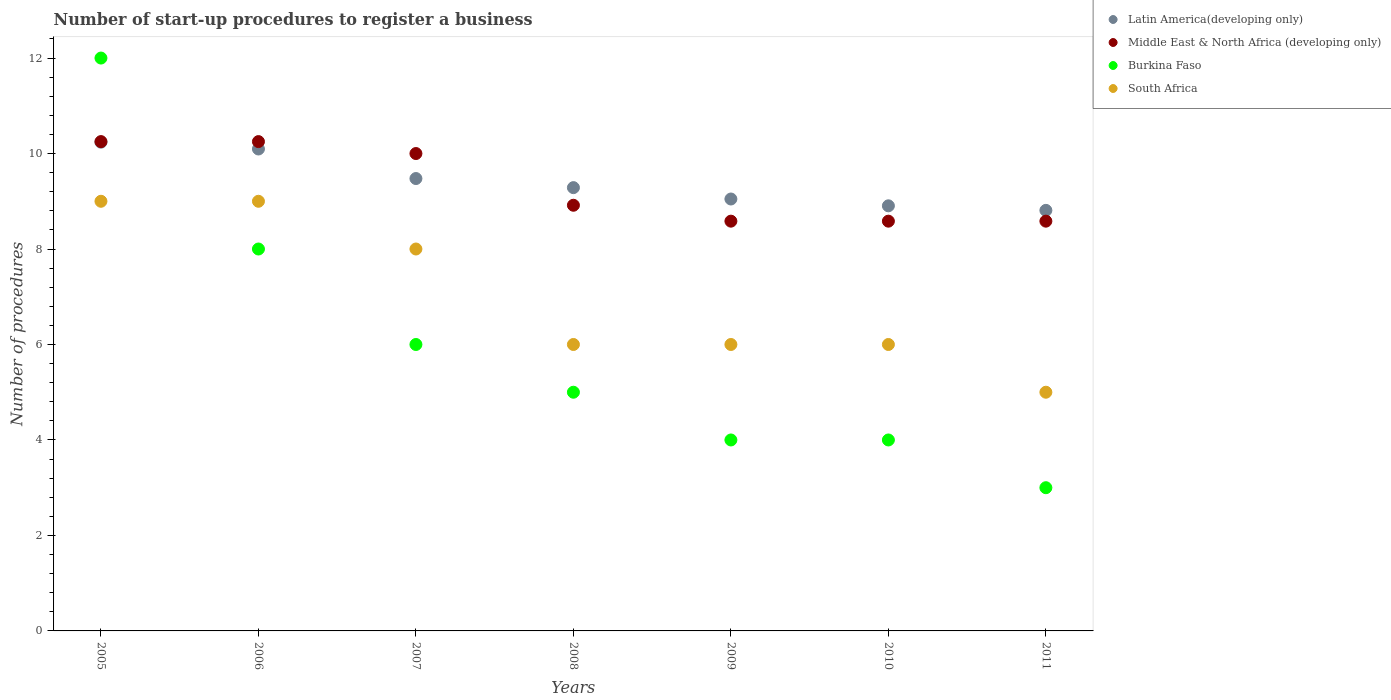How many different coloured dotlines are there?
Your answer should be compact. 4. What is the number of procedures required to register a business in Middle East & North Africa (developing only) in 2006?
Make the answer very short. 10.25. Across all years, what is the maximum number of procedures required to register a business in South Africa?
Your response must be concise. 9. Across all years, what is the minimum number of procedures required to register a business in Latin America(developing only)?
Your answer should be very brief. 8.81. What is the total number of procedures required to register a business in Middle East & North Africa (developing only) in the graph?
Make the answer very short. 65.17. What is the difference between the number of procedures required to register a business in Middle East & North Africa (developing only) in 2006 and that in 2009?
Your answer should be compact. 1.67. What is the difference between the number of procedures required to register a business in South Africa in 2011 and the number of procedures required to register a business in Burkina Faso in 2005?
Make the answer very short. -7. What is the average number of procedures required to register a business in Burkina Faso per year?
Offer a terse response. 6. In the year 2009, what is the difference between the number of procedures required to register a business in Latin America(developing only) and number of procedures required to register a business in South Africa?
Offer a terse response. 3.05. What is the ratio of the number of procedures required to register a business in Latin America(developing only) in 2008 to that in 2010?
Ensure brevity in your answer.  1.04. Is the difference between the number of procedures required to register a business in Latin America(developing only) in 2005 and 2007 greater than the difference between the number of procedures required to register a business in South Africa in 2005 and 2007?
Make the answer very short. No. What is the difference between the highest and the lowest number of procedures required to register a business in Burkina Faso?
Offer a terse response. 9. In how many years, is the number of procedures required to register a business in Middle East & North Africa (developing only) greater than the average number of procedures required to register a business in Middle East & North Africa (developing only) taken over all years?
Offer a very short reply. 3. Is the sum of the number of procedures required to register a business in South Africa in 2005 and 2010 greater than the maximum number of procedures required to register a business in Middle East & North Africa (developing only) across all years?
Ensure brevity in your answer.  Yes. Is the number of procedures required to register a business in Latin America(developing only) strictly greater than the number of procedures required to register a business in Burkina Faso over the years?
Your response must be concise. No. Is the number of procedures required to register a business in South Africa strictly less than the number of procedures required to register a business in Latin America(developing only) over the years?
Provide a succinct answer. Yes. Are the values on the major ticks of Y-axis written in scientific E-notation?
Give a very brief answer. No. Does the graph contain grids?
Offer a terse response. No. Where does the legend appear in the graph?
Give a very brief answer. Top right. How are the legend labels stacked?
Your answer should be compact. Vertical. What is the title of the graph?
Your answer should be very brief. Number of start-up procedures to register a business. Does "Congo (Democratic)" appear as one of the legend labels in the graph?
Your answer should be compact. No. What is the label or title of the Y-axis?
Provide a short and direct response. Number of procedures. What is the Number of procedures in Latin America(developing only) in 2005?
Give a very brief answer. 10.24. What is the Number of procedures of Middle East & North Africa (developing only) in 2005?
Provide a short and direct response. 10.25. What is the Number of procedures in South Africa in 2005?
Your answer should be compact. 9. What is the Number of procedures of Latin America(developing only) in 2006?
Give a very brief answer. 10.1. What is the Number of procedures of Middle East & North Africa (developing only) in 2006?
Offer a very short reply. 10.25. What is the Number of procedures in Latin America(developing only) in 2007?
Keep it short and to the point. 9.48. What is the Number of procedures of South Africa in 2007?
Give a very brief answer. 8. What is the Number of procedures in Latin America(developing only) in 2008?
Make the answer very short. 9.29. What is the Number of procedures in Middle East & North Africa (developing only) in 2008?
Offer a terse response. 8.92. What is the Number of procedures of South Africa in 2008?
Your answer should be compact. 6. What is the Number of procedures in Latin America(developing only) in 2009?
Ensure brevity in your answer.  9.05. What is the Number of procedures of Middle East & North Africa (developing only) in 2009?
Offer a terse response. 8.58. What is the Number of procedures in South Africa in 2009?
Your answer should be very brief. 6. What is the Number of procedures in Latin America(developing only) in 2010?
Your answer should be very brief. 8.9. What is the Number of procedures in Middle East & North Africa (developing only) in 2010?
Offer a very short reply. 8.58. What is the Number of procedures of Burkina Faso in 2010?
Keep it short and to the point. 4. What is the Number of procedures of South Africa in 2010?
Your response must be concise. 6. What is the Number of procedures in Latin America(developing only) in 2011?
Offer a terse response. 8.81. What is the Number of procedures in Middle East & North Africa (developing only) in 2011?
Ensure brevity in your answer.  8.58. What is the Number of procedures in Burkina Faso in 2011?
Make the answer very short. 3. What is the Number of procedures in South Africa in 2011?
Ensure brevity in your answer.  5. Across all years, what is the maximum Number of procedures of Latin America(developing only)?
Offer a very short reply. 10.24. Across all years, what is the maximum Number of procedures of Middle East & North Africa (developing only)?
Offer a terse response. 10.25. Across all years, what is the maximum Number of procedures in South Africa?
Offer a very short reply. 9. Across all years, what is the minimum Number of procedures in Latin America(developing only)?
Provide a succinct answer. 8.81. Across all years, what is the minimum Number of procedures of Middle East & North Africa (developing only)?
Offer a terse response. 8.58. Across all years, what is the minimum Number of procedures in South Africa?
Keep it short and to the point. 5. What is the total Number of procedures in Latin America(developing only) in the graph?
Ensure brevity in your answer.  65.86. What is the total Number of procedures in Middle East & North Africa (developing only) in the graph?
Provide a succinct answer. 65.17. What is the total Number of procedures of Burkina Faso in the graph?
Provide a short and direct response. 42. What is the total Number of procedures of South Africa in the graph?
Make the answer very short. 49. What is the difference between the Number of procedures in Latin America(developing only) in 2005 and that in 2006?
Your response must be concise. 0.14. What is the difference between the Number of procedures of Burkina Faso in 2005 and that in 2006?
Your response must be concise. 4. What is the difference between the Number of procedures in South Africa in 2005 and that in 2006?
Your answer should be very brief. 0. What is the difference between the Number of procedures of Latin America(developing only) in 2005 and that in 2007?
Offer a terse response. 0.76. What is the difference between the Number of procedures of Latin America(developing only) in 2005 and that in 2009?
Your answer should be compact. 1.19. What is the difference between the Number of procedures in Middle East & North Africa (developing only) in 2005 and that in 2009?
Your answer should be very brief. 1.67. What is the difference between the Number of procedures in Burkina Faso in 2005 and that in 2009?
Provide a succinct answer. 8. What is the difference between the Number of procedures of Latin America(developing only) in 2005 and that in 2010?
Provide a succinct answer. 1.33. What is the difference between the Number of procedures in Middle East & North Africa (developing only) in 2005 and that in 2010?
Offer a terse response. 1.67. What is the difference between the Number of procedures in Latin America(developing only) in 2005 and that in 2011?
Offer a terse response. 1.43. What is the difference between the Number of procedures of Burkina Faso in 2005 and that in 2011?
Ensure brevity in your answer.  9. What is the difference between the Number of procedures in South Africa in 2005 and that in 2011?
Ensure brevity in your answer.  4. What is the difference between the Number of procedures of Latin America(developing only) in 2006 and that in 2007?
Keep it short and to the point. 0.62. What is the difference between the Number of procedures in Middle East & North Africa (developing only) in 2006 and that in 2007?
Provide a succinct answer. 0.25. What is the difference between the Number of procedures of Burkina Faso in 2006 and that in 2007?
Provide a succinct answer. 2. What is the difference between the Number of procedures of Latin America(developing only) in 2006 and that in 2008?
Provide a short and direct response. 0.81. What is the difference between the Number of procedures in Burkina Faso in 2006 and that in 2008?
Provide a succinct answer. 3. What is the difference between the Number of procedures in South Africa in 2006 and that in 2008?
Your answer should be very brief. 3. What is the difference between the Number of procedures in Latin America(developing only) in 2006 and that in 2009?
Offer a very short reply. 1.05. What is the difference between the Number of procedures of Burkina Faso in 2006 and that in 2009?
Your response must be concise. 4. What is the difference between the Number of procedures in South Africa in 2006 and that in 2009?
Your answer should be compact. 3. What is the difference between the Number of procedures of Latin America(developing only) in 2006 and that in 2010?
Offer a terse response. 1.19. What is the difference between the Number of procedures in Middle East & North Africa (developing only) in 2006 and that in 2010?
Provide a short and direct response. 1.67. What is the difference between the Number of procedures of Burkina Faso in 2006 and that in 2010?
Give a very brief answer. 4. What is the difference between the Number of procedures in Latin America(developing only) in 2006 and that in 2011?
Keep it short and to the point. 1.29. What is the difference between the Number of procedures in Middle East & North Africa (developing only) in 2006 and that in 2011?
Your response must be concise. 1.67. What is the difference between the Number of procedures of Burkina Faso in 2006 and that in 2011?
Ensure brevity in your answer.  5. What is the difference between the Number of procedures of Latin America(developing only) in 2007 and that in 2008?
Offer a terse response. 0.19. What is the difference between the Number of procedures of Middle East & North Africa (developing only) in 2007 and that in 2008?
Your answer should be very brief. 1.08. What is the difference between the Number of procedures of South Africa in 2007 and that in 2008?
Your answer should be very brief. 2. What is the difference between the Number of procedures of Latin America(developing only) in 2007 and that in 2009?
Your answer should be compact. 0.43. What is the difference between the Number of procedures in Middle East & North Africa (developing only) in 2007 and that in 2009?
Give a very brief answer. 1.42. What is the difference between the Number of procedures in Latin America(developing only) in 2007 and that in 2010?
Make the answer very short. 0.57. What is the difference between the Number of procedures in Middle East & North Africa (developing only) in 2007 and that in 2010?
Offer a very short reply. 1.42. What is the difference between the Number of procedures of Burkina Faso in 2007 and that in 2010?
Give a very brief answer. 2. What is the difference between the Number of procedures of Latin America(developing only) in 2007 and that in 2011?
Keep it short and to the point. 0.67. What is the difference between the Number of procedures in Middle East & North Africa (developing only) in 2007 and that in 2011?
Give a very brief answer. 1.42. What is the difference between the Number of procedures of South Africa in 2007 and that in 2011?
Give a very brief answer. 3. What is the difference between the Number of procedures in Latin America(developing only) in 2008 and that in 2009?
Provide a succinct answer. 0.24. What is the difference between the Number of procedures in Latin America(developing only) in 2008 and that in 2010?
Your answer should be compact. 0.38. What is the difference between the Number of procedures of Burkina Faso in 2008 and that in 2010?
Keep it short and to the point. 1. What is the difference between the Number of procedures of South Africa in 2008 and that in 2010?
Make the answer very short. 0. What is the difference between the Number of procedures in Latin America(developing only) in 2008 and that in 2011?
Provide a succinct answer. 0.48. What is the difference between the Number of procedures of Middle East & North Africa (developing only) in 2008 and that in 2011?
Your answer should be very brief. 0.33. What is the difference between the Number of procedures of South Africa in 2008 and that in 2011?
Provide a succinct answer. 1. What is the difference between the Number of procedures of Latin America(developing only) in 2009 and that in 2010?
Give a very brief answer. 0.14. What is the difference between the Number of procedures of Burkina Faso in 2009 and that in 2010?
Your response must be concise. 0. What is the difference between the Number of procedures of Latin America(developing only) in 2009 and that in 2011?
Give a very brief answer. 0.24. What is the difference between the Number of procedures in Latin America(developing only) in 2010 and that in 2011?
Your response must be concise. 0.1. What is the difference between the Number of procedures of Middle East & North Africa (developing only) in 2010 and that in 2011?
Your response must be concise. 0. What is the difference between the Number of procedures of South Africa in 2010 and that in 2011?
Provide a short and direct response. 1. What is the difference between the Number of procedures of Latin America(developing only) in 2005 and the Number of procedures of Middle East & North Africa (developing only) in 2006?
Ensure brevity in your answer.  -0.01. What is the difference between the Number of procedures of Latin America(developing only) in 2005 and the Number of procedures of Burkina Faso in 2006?
Give a very brief answer. 2.24. What is the difference between the Number of procedures of Latin America(developing only) in 2005 and the Number of procedures of South Africa in 2006?
Provide a short and direct response. 1.24. What is the difference between the Number of procedures of Middle East & North Africa (developing only) in 2005 and the Number of procedures of Burkina Faso in 2006?
Give a very brief answer. 2.25. What is the difference between the Number of procedures in Burkina Faso in 2005 and the Number of procedures in South Africa in 2006?
Your answer should be compact. 3. What is the difference between the Number of procedures of Latin America(developing only) in 2005 and the Number of procedures of Middle East & North Africa (developing only) in 2007?
Provide a succinct answer. 0.24. What is the difference between the Number of procedures in Latin America(developing only) in 2005 and the Number of procedures in Burkina Faso in 2007?
Provide a succinct answer. 4.24. What is the difference between the Number of procedures of Latin America(developing only) in 2005 and the Number of procedures of South Africa in 2007?
Your answer should be very brief. 2.24. What is the difference between the Number of procedures in Middle East & North Africa (developing only) in 2005 and the Number of procedures in Burkina Faso in 2007?
Your response must be concise. 4.25. What is the difference between the Number of procedures of Middle East & North Africa (developing only) in 2005 and the Number of procedures of South Africa in 2007?
Provide a succinct answer. 2.25. What is the difference between the Number of procedures in Latin America(developing only) in 2005 and the Number of procedures in Middle East & North Africa (developing only) in 2008?
Make the answer very short. 1.32. What is the difference between the Number of procedures of Latin America(developing only) in 2005 and the Number of procedures of Burkina Faso in 2008?
Offer a very short reply. 5.24. What is the difference between the Number of procedures of Latin America(developing only) in 2005 and the Number of procedures of South Africa in 2008?
Make the answer very short. 4.24. What is the difference between the Number of procedures of Middle East & North Africa (developing only) in 2005 and the Number of procedures of Burkina Faso in 2008?
Keep it short and to the point. 5.25. What is the difference between the Number of procedures in Middle East & North Africa (developing only) in 2005 and the Number of procedures in South Africa in 2008?
Give a very brief answer. 4.25. What is the difference between the Number of procedures in Latin America(developing only) in 2005 and the Number of procedures in Middle East & North Africa (developing only) in 2009?
Offer a very short reply. 1.65. What is the difference between the Number of procedures of Latin America(developing only) in 2005 and the Number of procedures of Burkina Faso in 2009?
Your answer should be compact. 6.24. What is the difference between the Number of procedures in Latin America(developing only) in 2005 and the Number of procedures in South Africa in 2009?
Ensure brevity in your answer.  4.24. What is the difference between the Number of procedures of Middle East & North Africa (developing only) in 2005 and the Number of procedures of Burkina Faso in 2009?
Keep it short and to the point. 6.25. What is the difference between the Number of procedures in Middle East & North Africa (developing only) in 2005 and the Number of procedures in South Africa in 2009?
Make the answer very short. 4.25. What is the difference between the Number of procedures in Latin America(developing only) in 2005 and the Number of procedures in Middle East & North Africa (developing only) in 2010?
Ensure brevity in your answer.  1.65. What is the difference between the Number of procedures of Latin America(developing only) in 2005 and the Number of procedures of Burkina Faso in 2010?
Provide a short and direct response. 6.24. What is the difference between the Number of procedures of Latin America(developing only) in 2005 and the Number of procedures of South Africa in 2010?
Offer a terse response. 4.24. What is the difference between the Number of procedures of Middle East & North Africa (developing only) in 2005 and the Number of procedures of Burkina Faso in 2010?
Your answer should be compact. 6.25. What is the difference between the Number of procedures in Middle East & North Africa (developing only) in 2005 and the Number of procedures in South Africa in 2010?
Offer a terse response. 4.25. What is the difference between the Number of procedures of Burkina Faso in 2005 and the Number of procedures of South Africa in 2010?
Provide a succinct answer. 6. What is the difference between the Number of procedures of Latin America(developing only) in 2005 and the Number of procedures of Middle East & North Africa (developing only) in 2011?
Offer a very short reply. 1.65. What is the difference between the Number of procedures of Latin America(developing only) in 2005 and the Number of procedures of Burkina Faso in 2011?
Your answer should be very brief. 7.24. What is the difference between the Number of procedures of Latin America(developing only) in 2005 and the Number of procedures of South Africa in 2011?
Ensure brevity in your answer.  5.24. What is the difference between the Number of procedures in Middle East & North Africa (developing only) in 2005 and the Number of procedures in Burkina Faso in 2011?
Offer a very short reply. 7.25. What is the difference between the Number of procedures in Middle East & North Africa (developing only) in 2005 and the Number of procedures in South Africa in 2011?
Make the answer very short. 5.25. What is the difference between the Number of procedures in Latin America(developing only) in 2006 and the Number of procedures in Middle East & North Africa (developing only) in 2007?
Offer a very short reply. 0.1. What is the difference between the Number of procedures in Latin America(developing only) in 2006 and the Number of procedures in Burkina Faso in 2007?
Your response must be concise. 4.1. What is the difference between the Number of procedures of Latin America(developing only) in 2006 and the Number of procedures of South Africa in 2007?
Make the answer very short. 2.1. What is the difference between the Number of procedures in Middle East & North Africa (developing only) in 2006 and the Number of procedures in Burkina Faso in 2007?
Your answer should be compact. 4.25. What is the difference between the Number of procedures in Middle East & North Africa (developing only) in 2006 and the Number of procedures in South Africa in 2007?
Offer a very short reply. 2.25. What is the difference between the Number of procedures of Burkina Faso in 2006 and the Number of procedures of South Africa in 2007?
Provide a succinct answer. 0. What is the difference between the Number of procedures of Latin America(developing only) in 2006 and the Number of procedures of Middle East & North Africa (developing only) in 2008?
Offer a very short reply. 1.18. What is the difference between the Number of procedures of Latin America(developing only) in 2006 and the Number of procedures of Burkina Faso in 2008?
Your answer should be very brief. 5.1. What is the difference between the Number of procedures in Latin America(developing only) in 2006 and the Number of procedures in South Africa in 2008?
Give a very brief answer. 4.1. What is the difference between the Number of procedures in Middle East & North Africa (developing only) in 2006 and the Number of procedures in Burkina Faso in 2008?
Provide a short and direct response. 5.25. What is the difference between the Number of procedures in Middle East & North Africa (developing only) in 2006 and the Number of procedures in South Africa in 2008?
Your answer should be very brief. 4.25. What is the difference between the Number of procedures of Burkina Faso in 2006 and the Number of procedures of South Africa in 2008?
Your answer should be very brief. 2. What is the difference between the Number of procedures in Latin America(developing only) in 2006 and the Number of procedures in Middle East & North Africa (developing only) in 2009?
Your answer should be compact. 1.51. What is the difference between the Number of procedures of Latin America(developing only) in 2006 and the Number of procedures of Burkina Faso in 2009?
Keep it short and to the point. 6.1. What is the difference between the Number of procedures of Latin America(developing only) in 2006 and the Number of procedures of South Africa in 2009?
Make the answer very short. 4.1. What is the difference between the Number of procedures of Middle East & North Africa (developing only) in 2006 and the Number of procedures of Burkina Faso in 2009?
Provide a succinct answer. 6.25. What is the difference between the Number of procedures in Middle East & North Africa (developing only) in 2006 and the Number of procedures in South Africa in 2009?
Your response must be concise. 4.25. What is the difference between the Number of procedures of Burkina Faso in 2006 and the Number of procedures of South Africa in 2009?
Your answer should be compact. 2. What is the difference between the Number of procedures in Latin America(developing only) in 2006 and the Number of procedures in Middle East & North Africa (developing only) in 2010?
Provide a succinct answer. 1.51. What is the difference between the Number of procedures in Latin America(developing only) in 2006 and the Number of procedures in Burkina Faso in 2010?
Provide a succinct answer. 6.1. What is the difference between the Number of procedures in Latin America(developing only) in 2006 and the Number of procedures in South Africa in 2010?
Provide a short and direct response. 4.1. What is the difference between the Number of procedures in Middle East & North Africa (developing only) in 2006 and the Number of procedures in Burkina Faso in 2010?
Give a very brief answer. 6.25. What is the difference between the Number of procedures in Middle East & North Africa (developing only) in 2006 and the Number of procedures in South Africa in 2010?
Ensure brevity in your answer.  4.25. What is the difference between the Number of procedures of Burkina Faso in 2006 and the Number of procedures of South Africa in 2010?
Your answer should be compact. 2. What is the difference between the Number of procedures of Latin America(developing only) in 2006 and the Number of procedures of Middle East & North Africa (developing only) in 2011?
Provide a succinct answer. 1.51. What is the difference between the Number of procedures in Latin America(developing only) in 2006 and the Number of procedures in Burkina Faso in 2011?
Give a very brief answer. 7.1. What is the difference between the Number of procedures of Latin America(developing only) in 2006 and the Number of procedures of South Africa in 2011?
Offer a terse response. 5.1. What is the difference between the Number of procedures of Middle East & North Africa (developing only) in 2006 and the Number of procedures of Burkina Faso in 2011?
Give a very brief answer. 7.25. What is the difference between the Number of procedures in Middle East & North Africa (developing only) in 2006 and the Number of procedures in South Africa in 2011?
Provide a short and direct response. 5.25. What is the difference between the Number of procedures of Burkina Faso in 2006 and the Number of procedures of South Africa in 2011?
Make the answer very short. 3. What is the difference between the Number of procedures of Latin America(developing only) in 2007 and the Number of procedures of Middle East & North Africa (developing only) in 2008?
Your response must be concise. 0.56. What is the difference between the Number of procedures in Latin America(developing only) in 2007 and the Number of procedures in Burkina Faso in 2008?
Provide a succinct answer. 4.48. What is the difference between the Number of procedures of Latin America(developing only) in 2007 and the Number of procedures of South Africa in 2008?
Your response must be concise. 3.48. What is the difference between the Number of procedures in Burkina Faso in 2007 and the Number of procedures in South Africa in 2008?
Provide a succinct answer. 0. What is the difference between the Number of procedures of Latin America(developing only) in 2007 and the Number of procedures of Middle East & North Africa (developing only) in 2009?
Give a very brief answer. 0.89. What is the difference between the Number of procedures of Latin America(developing only) in 2007 and the Number of procedures of Burkina Faso in 2009?
Give a very brief answer. 5.48. What is the difference between the Number of procedures in Latin America(developing only) in 2007 and the Number of procedures in South Africa in 2009?
Offer a terse response. 3.48. What is the difference between the Number of procedures of Middle East & North Africa (developing only) in 2007 and the Number of procedures of Burkina Faso in 2009?
Give a very brief answer. 6. What is the difference between the Number of procedures in Middle East & North Africa (developing only) in 2007 and the Number of procedures in South Africa in 2009?
Offer a very short reply. 4. What is the difference between the Number of procedures of Latin America(developing only) in 2007 and the Number of procedures of Middle East & North Africa (developing only) in 2010?
Your answer should be compact. 0.89. What is the difference between the Number of procedures in Latin America(developing only) in 2007 and the Number of procedures in Burkina Faso in 2010?
Your answer should be compact. 5.48. What is the difference between the Number of procedures in Latin America(developing only) in 2007 and the Number of procedures in South Africa in 2010?
Keep it short and to the point. 3.48. What is the difference between the Number of procedures of Middle East & North Africa (developing only) in 2007 and the Number of procedures of South Africa in 2010?
Offer a terse response. 4. What is the difference between the Number of procedures of Latin America(developing only) in 2007 and the Number of procedures of Middle East & North Africa (developing only) in 2011?
Ensure brevity in your answer.  0.89. What is the difference between the Number of procedures of Latin America(developing only) in 2007 and the Number of procedures of Burkina Faso in 2011?
Keep it short and to the point. 6.48. What is the difference between the Number of procedures in Latin America(developing only) in 2007 and the Number of procedures in South Africa in 2011?
Ensure brevity in your answer.  4.48. What is the difference between the Number of procedures of Middle East & North Africa (developing only) in 2007 and the Number of procedures of Burkina Faso in 2011?
Offer a very short reply. 7. What is the difference between the Number of procedures in Middle East & North Africa (developing only) in 2007 and the Number of procedures in South Africa in 2011?
Your response must be concise. 5. What is the difference between the Number of procedures in Latin America(developing only) in 2008 and the Number of procedures in Middle East & North Africa (developing only) in 2009?
Offer a terse response. 0.7. What is the difference between the Number of procedures in Latin America(developing only) in 2008 and the Number of procedures in Burkina Faso in 2009?
Offer a very short reply. 5.29. What is the difference between the Number of procedures of Latin America(developing only) in 2008 and the Number of procedures of South Africa in 2009?
Give a very brief answer. 3.29. What is the difference between the Number of procedures in Middle East & North Africa (developing only) in 2008 and the Number of procedures in Burkina Faso in 2009?
Keep it short and to the point. 4.92. What is the difference between the Number of procedures in Middle East & North Africa (developing only) in 2008 and the Number of procedures in South Africa in 2009?
Offer a terse response. 2.92. What is the difference between the Number of procedures of Latin America(developing only) in 2008 and the Number of procedures of Middle East & North Africa (developing only) in 2010?
Provide a succinct answer. 0.7. What is the difference between the Number of procedures in Latin America(developing only) in 2008 and the Number of procedures in Burkina Faso in 2010?
Your answer should be very brief. 5.29. What is the difference between the Number of procedures in Latin America(developing only) in 2008 and the Number of procedures in South Africa in 2010?
Give a very brief answer. 3.29. What is the difference between the Number of procedures in Middle East & North Africa (developing only) in 2008 and the Number of procedures in Burkina Faso in 2010?
Your response must be concise. 4.92. What is the difference between the Number of procedures of Middle East & North Africa (developing only) in 2008 and the Number of procedures of South Africa in 2010?
Give a very brief answer. 2.92. What is the difference between the Number of procedures in Burkina Faso in 2008 and the Number of procedures in South Africa in 2010?
Offer a very short reply. -1. What is the difference between the Number of procedures of Latin America(developing only) in 2008 and the Number of procedures of Middle East & North Africa (developing only) in 2011?
Your response must be concise. 0.7. What is the difference between the Number of procedures of Latin America(developing only) in 2008 and the Number of procedures of Burkina Faso in 2011?
Make the answer very short. 6.29. What is the difference between the Number of procedures of Latin America(developing only) in 2008 and the Number of procedures of South Africa in 2011?
Offer a very short reply. 4.29. What is the difference between the Number of procedures of Middle East & North Africa (developing only) in 2008 and the Number of procedures of Burkina Faso in 2011?
Keep it short and to the point. 5.92. What is the difference between the Number of procedures of Middle East & North Africa (developing only) in 2008 and the Number of procedures of South Africa in 2011?
Your response must be concise. 3.92. What is the difference between the Number of procedures in Latin America(developing only) in 2009 and the Number of procedures in Middle East & North Africa (developing only) in 2010?
Give a very brief answer. 0.46. What is the difference between the Number of procedures of Latin America(developing only) in 2009 and the Number of procedures of Burkina Faso in 2010?
Ensure brevity in your answer.  5.05. What is the difference between the Number of procedures of Latin America(developing only) in 2009 and the Number of procedures of South Africa in 2010?
Your answer should be very brief. 3.05. What is the difference between the Number of procedures of Middle East & North Africa (developing only) in 2009 and the Number of procedures of Burkina Faso in 2010?
Make the answer very short. 4.58. What is the difference between the Number of procedures in Middle East & North Africa (developing only) in 2009 and the Number of procedures in South Africa in 2010?
Provide a succinct answer. 2.58. What is the difference between the Number of procedures in Latin America(developing only) in 2009 and the Number of procedures in Middle East & North Africa (developing only) in 2011?
Ensure brevity in your answer.  0.46. What is the difference between the Number of procedures of Latin America(developing only) in 2009 and the Number of procedures of Burkina Faso in 2011?
Provide a succinct answer. 6.05. What is the difference between the Number of procedures in Latin America(developing only) in 2009 and the Number of procedures in South Africa in 2011?
Make the answer very short. 4.05. What is the difference between the Number of procedures of Middle East & North Africa (developing only) in 2009 and the Number of procedures of Burkina Faso in 2011?
Keep it short and to the point. 5.58. What is the difference between the Number of procedures in Middle East & North Africa (developing only) in 2009 and the Number of procedures in South Africa in 2011?
Provide a short and direct response. 3.58. What is the difference between the Number of procedures of Burkina Faso in 2009 and the Number of procedures of South Africa in 2011?
Offer a terse response. -1. What is the difference between the Number of procedures in Latin America(developing only) in 2010 and the Number of procedures in Middle East & North Africa (developing only) in 2011?
Ensure brevity in your answer.  0.32. What is the difference between the Number of procedures in Latin America(developing only) in 2010 and the Number of procedures in Burkina Faso in 2011?
Your response must be concise. 5.9. What is the difference between the Number of procedures in Latin America(developing only) in 2010 and the Number of procedures in South Africa in 2011?
Give a very brief answer. 3.9. What is the difference between the Number of procedures of Middle East & North Africa (developing only) in 2010 and the Number of procedures of Burkina Faso in 2011?
Your response must be concise. 5.58. What is the difference between the Number of procedures of Middle East & North Africa (developing only) in 2010 and the Number of procedures of South Africa in 2011?
Provide a short and direct response. 3.58. What is the difference between the Number of procedures in Burkina Faso in 2010 and the Number of procedures in South Africa in 2011?
Give a very brief answer. -1. What is the average Number of procedures of Latin America(developing only) per year?
Keep it short and to the point. 9.41. What is the average Number of procedures of Middle East & North Africa (developing only) per year?
Offer a very short reply. 9.31. What is the average Number of procedures in Burkina Faso per year?
Keep it short and to the point. 6. What is the average Number of procedures of South Africa per year?
Ensure brevity in your answer.  7. In the year 2005, what is the difference between the Number of procedures in Latin America(developing only) and Number of procedures in Middle East & North Africa (developing only)?
Offer a very short reply. -0.01. In the year 2005, what is the difference between the Number of procedures in Latin America(developing only) and Number of procedures in Burkina Faso?
Provide a succinct answer. -1.76. In the year 2005, what is the difference between the Number of procedures in Latin America(developing only) and Number of procedures in South Africa?
Provide a succinct answer. 1.24. In the year 2005, what is the difference between the Number of procedures in Middle East & North Africa (developing only) and Number of procedures in Burkina Faso?
Give a very brief answer. -1.75. In the year 2005, what is the difference between the Number of procedures of Burkina Faso and Number of procedures of South Africa?
Provide a short and direct response. 3. In the year 2006, what is the difference between the Number of procedures of Latin America(developing only) and Number of procedures of Middle East & North Africa (developing only)?
Your answer should be very brief. -0.15. In the year 2006, what is the difference between the Number of procedures of Latin America(developing only) and Number of procedures of Burkina Faso?
Provide a short and direct response. 2.1. In the year 2006, what is the difference between the Number of procedures in Latin America(developing only) and Number of procedures in South Africa?
Offer a terse response. 1.1. In the year 2006, what is the difference between the Number of procedures of Middle East & North Africa (developing only) and Number of procedures of Burkina Faso?
Give a very brief answer. 2.25. In the year 2007, what is the difference between the Number of procedures of Latin America(developing only) and Number of procedures of Middle East & North Africa (developing only)?
Your response must be concise. -0.52. In the year 2007, what is the difference between the Number of procedures in Latin America(developing only) and Number of procedures in Burkina Faso?
Give a very brief answer. 3.48. In the year 2007, what is the difference between the Number of procedures of Latin America(developing only) and Number of procedures of South Africa?
Offer a very short reply. 1.48. In the year 2007, what is the difference between the Number of procedures of Middle East & North Africa (developing only) and Number of procedures of Burkina Faso?
Give a very brief answer. 4. In the year 2008, what is the difference between the Number of procedures of Latin America(developing only) and Number of procedures of Middle East & North Africa (developing only)?
Make the answer very short. 0.37. In the year 2008, what is the difference between the Number of procedures in Latin America(developing only) and Number of procedures in Burkina Faso?
Offer a terse response. 4.29. In the year 2008, what is the difference between the Number of procedures of Latin America(developing only) and Number of procedures of South Africa?
Your response must be concise. 3.29. In the year 2008, what is the difference between the Number of procedures of Middle East & North Africa (developing only) and Number of procedures of Burkina Faso?
Your answer should be very brief. 3.92. In the year 2008, what is the difference between the Number of procedures of Middle East & North Africa (developing only) and Number of procedures of South Africa?
Offer a very short reply. 2.92. In the year 2008, what is the difference between the Number of procedures of Burkina Faso and Number of procedures of South Africa?
Your answer should be very brief. -1. In the year 2009, what is the difference between the Number of procedures of Latin America(developing only) and Number of procedures of Middle East & North Africa (developing only)?
Provide a short and direct response. 0.46. In the year 2009, what is the difference between the Number of procedures of Latin America(developing only) and Number of procedures of Burkina Faso?
Keep it short and to the point. 5.05. In the year 2009, what is the difference between the Number of procedures in Latin America(developing only) and Number of procedures in South Africa?
Make the answer very short. 3.05. In the year 2009, what is the difference between the Number of procedures in Middle East & North Africa (developing only) and Number of procedures in Burkina Faso?
Your response must be concise. 4.58. In the year 2009, what is the difference between the Number of procedures of Middle East & North Africa (developing only) and Number of procedures of South Africa?
Your answer should be very brief. 2.58. In the year 2010, what is the difference between the Number of procedures of Latin America(developing only) and Number of procedures of Middle East & North Africa (developing only)?
Your answer should be compact. 0.32. In the year 2010, what is the difference between the Number of procedures of Latin America(developing only) and Number of procedures of Burkina Faso?
Ensure brevity in your answer.  4.9. In the year 2010, what is the difference between the Number of procedures of Latin America(developing only) and Number of procedures of South Africa?
Make the answer very short. 2.9. In the year 2010, what is the difference between the Number of procedures of Middle East & North Africa (developing only) and Number of procedures of Burkina Faso?
Offer a terse response. 4.58. In the year 2010, what is the difference between the Number of procedures in Middle East & North Africa (developing only) and Number of procedures in South Africa?
Your answer should be very brief. 2.58. In the year 2011, what is the difference between the Number of procedures in Latin America(developing only) and Number of procedures in Middle East & North Africa (developing only)?
Provide a succinct answer. 0.23. In the year 2011, what is the difference between the Number of procedures in Latin America(developing only) and Number of procedures in Burkina Faso?
Offer a terse response. 5.81. In the year 2011, what is the difference between the Number of procedures of Latin America(developing only) and Number of procedures of South Africa?
Give a very brief answer. 3.81. In the year 2011, what is the difference between the Number of procedures of Middle East & North Africa (developing only) and Number of procedures of Burkina Faso?
Give a very brief answer. 5.58. In the year 2011, what is the difference between the Number of procedures in Middle East & North Africa (developing only) and Number of procedures in South Africa?
Provide a succinct answer. 3.58. In the year 2011, what is the difference between the Number of procedures of Burkina Faso and Number of procedures of South Africa?
Ensure brevity in your answer.  -2. What is the ratio of the Number of procedures of Latin America(developing only) in 2005 to that in 2006?
Give a very brief answer. 1.01. What is the ratio of the Number of procedures in Latin America(developing only) in 2005 to that in 2007?
Provide a succinct answer. 1.08. What is the ratio of the Number of procedures of Latin America(developing only) in 2005 to that in 2008?
Keep it short and to the point. 1.1. What is the ratio of the Number of procedures of Middle East & North Africa (developing only) in 2005 to that in 2008?
Your response must be concise. 1.15. What is the ratio of the Number of procedures of Burkina Faso in 2005 to that in 2008?
Offer a very short reply. 2.4. What is the ratio of the Number of procedures of South Africa in 2005 to that in 2008?
Your answer should be compact. 1.5. What is the ratio of the Number of procedures of Latin America(developing only) in 2005 to that in 2009?
Your answer should be compact. 1.13. What is the ratio of the Number of procedures in Middle East & North Africa (developing only) in 2005 to that in 2009?
Your answer should be very brief. 1.19. What is the ratio of the Number of procedures of South Africa in 2005 to that in 2009?
Keep it short and to the point. 1.5. What is the ratio of the Number of procedures in Latin America(developing only) in 2005 to that in 2010?
Provide a short and direct response. 1.15. What is the ratio of the Number of procedures of Middle East & North Africa (developing only) in 2005 to that in 2010?
Your response must be concise. 1.19. What is the ratio of the Number of procedures of Burkina Faso in 2005 to that in 2010?
Ensure brevity in your answer.  3. What is the ratio of the Number of procedures of South Africa in 2005 to that in 2010?
Your answer should be compact. 1.5. What is the ratio of the Number of procedures in Latin America(developing only) in 2005 to that in 2011?
Provide a succinct answer. 1.16. What is the ratio of the Number of procedures of Middle East & North Africa (developing only) in 2005 to that in 2011?
Your response must be concise. 1.19. What is the ratio of the Number of procedures in South Africa in 2005 to that in 2011?
Keep it short and to the point. 1.8. What is the ratio of the Number of procedures of Latin America(developing only) in 2006 to that in 2007?
Offer a terse response. 1.07. What is the ratio of the Number of procedures of Latin America(developing only) in 2006 to that in 2008?
Your response must be concise. 1.09. What is the ratio of the Number of procedures of Middle East & North Africa (developing only) in 2006 to that in 2008?
Your answer should be very brief. 1.15. What is the ratio of the Number of procedures of Latin America(developing only) in 2006 to that in 2009?
Offer a terse response. 1.12. What is the ratio of the Number of procedures in Middle East & North Africa (developing only) in 2006 to that in 2009?
Provide a short and direct response. 1.19. What is the ratio of the Number of procedures of Burkina Faso in 2006 to that in 2009?
Provide a succinct answer. 2. What is the ratio of the Number of procedures in South Africa in 2006 to that in 2009?
Your answer should be compact. 1.5. What is the ratio of the Number of procedures of Latin America(developing only) in 2006 to that in 2010?
Keep it short and to the point. 1.13. What is the ratio of the Number of procedures of Middle East & North Africa (developing only) in 2006 to that in 2010?
Offer a terse response. 1.19. What is the ratio of the Number of procedures in South Africa in 2006 to that in 2010?
Provide a succinct answer. 1.5. What is the ratio of the Number of procedures of Latin America(developing only) in 2006 to that in 2011?
Make the answer very short. 1.15. What is the ratio of the Number of procedures of Middle East & North Africa (developing only) in 2006 to that in 2011?
Your answer should be very brief. 1.19. What is the ratio of the Number of procedures of Burkina Faso in 2006 to that in 2011?
Your answer should be very brief. 2.67. What is the ratio of the Number of procedures in Latin America(developing only) in 2007 to that in 2008?
Offer a terse response. 1.02. What is the ratio of the Number of procedures in Middle East & North Africa (developing only) in 2007 to that in 2008?
Offer a very short reply. 1.12. What is the ratio of the Number of procedures in Latin America(developing only) in 2007 to that in 2009?
Provide a succinct answer. 1.05. What is the ratio of the Number of procedures of Middle East & North Africa (developing only) in 2007 to that in 2009?
Ensure brevity in your answer.  1.17. What is the ratio of the Number of procedures of Burkina Faso in 2007 to that in 2009?
Ensure brevity in your answer.  1.5. What is the ratio of the Number of procedures in South Africa in 2007 to that in 2009?
Keep it short and to the point. 1.33. What is the ratio of the Number of procedures of Latin America(developing only) in 2007 to that in 2010?
Give a very brief answer. 1.06. What is the ratio of the Number of procedures in Middle East & North Africa (developing only) in 2007 to that in 2010?
Your answer should be compact. 1.17. What is the ratio of the Number of procedures of Latin America(developing only) in 2007 to that in 2011?
Keep it short and to the point. 1.08. What is the ratio of the Number of procedures of Middle East & North Africa (developing only) in 2007 to that in 2011?
Provide a short and direct response. 1.17. What is the ratio of the Number of procedures of South Africa in 2007 to that in 2011?
Offer a terse response. 1.6. What is the ratio of the Number of procedures of Latin America(developing only) in 2008 to that in 2009?
Provide a short and direct response. 1.03. What is the ratio of the Number of procedures in Middle East & North Africa (developing only) in 2008 to that in 2009?
Make the answer very short. 1.04. What is the ratio of the Number of procedures in Latin America(developing only) in 2008 to that in 2010?
Your answer should be compact. 1.04. What is the ratio of the Number of procedures of Middle East & North Africa (developing only) in 2008 to that in 2010?
Give a very brief answer. 1.04. What is the ratio of the Number of procedures in Burkina Faso in 2008 to that in 2010?
Offer a very short reply. 1.25. What is the ratio of the Number of procedures of South Africa in 2008 to that in 2010?
Give a very brief answer. 1. What is the ratio of the Number of procedures in Latin America(developing only) in 2008 to that in 2011?
Ensure brevity in your answer.  1.05. What is the ratio of the Number of procedures of Middle East & North Africa (developing only) in 2008 to that in 2011?
Provide a succinct answer. 1.04. What is the ratio of the Number of procedures of Middle East & North Africa (developing only) in 2009 to that in 2011?
Make the answer very short. 1. What is the ratio of the Number of procedures in Latin America(developing only) in 2010 to that in 2011?
Provide a succinct answer. 1.01. What is the ratio of the Number of procedures in Burkina Faso in 2010 to that in 2011?
Your answer should be very brief. 1.33. What is the ratio of the Number of procedures of South Africa in 2010 to that in 2011?
Your response must be concise. 1.2. What is the difference between the highest and the second highest Number of procedures of Latin America(developing only)?
Make the answer very short. 0.14. What is the difference between the highest and the second highest Number of procedures in Middle East & North Africa (developing only)?
Make the answer very short. 0. What is the difference between the highest and the second highest Number of procedures in Burkina Faso?
Provide a succinct answer. 4. What is the difference between the highest and the second highest Number of procedures in South Africa?
Your response must be concise. 0. What is the difference between the highest and the lowest Number of procedures of Latin America(developing only)?
Your answer should be compact. 1.43. What is the difference between the highest and the lowest Number of procedures of Middle East & North Africa (developing only)?
Give a very brief answer. 1.67. 